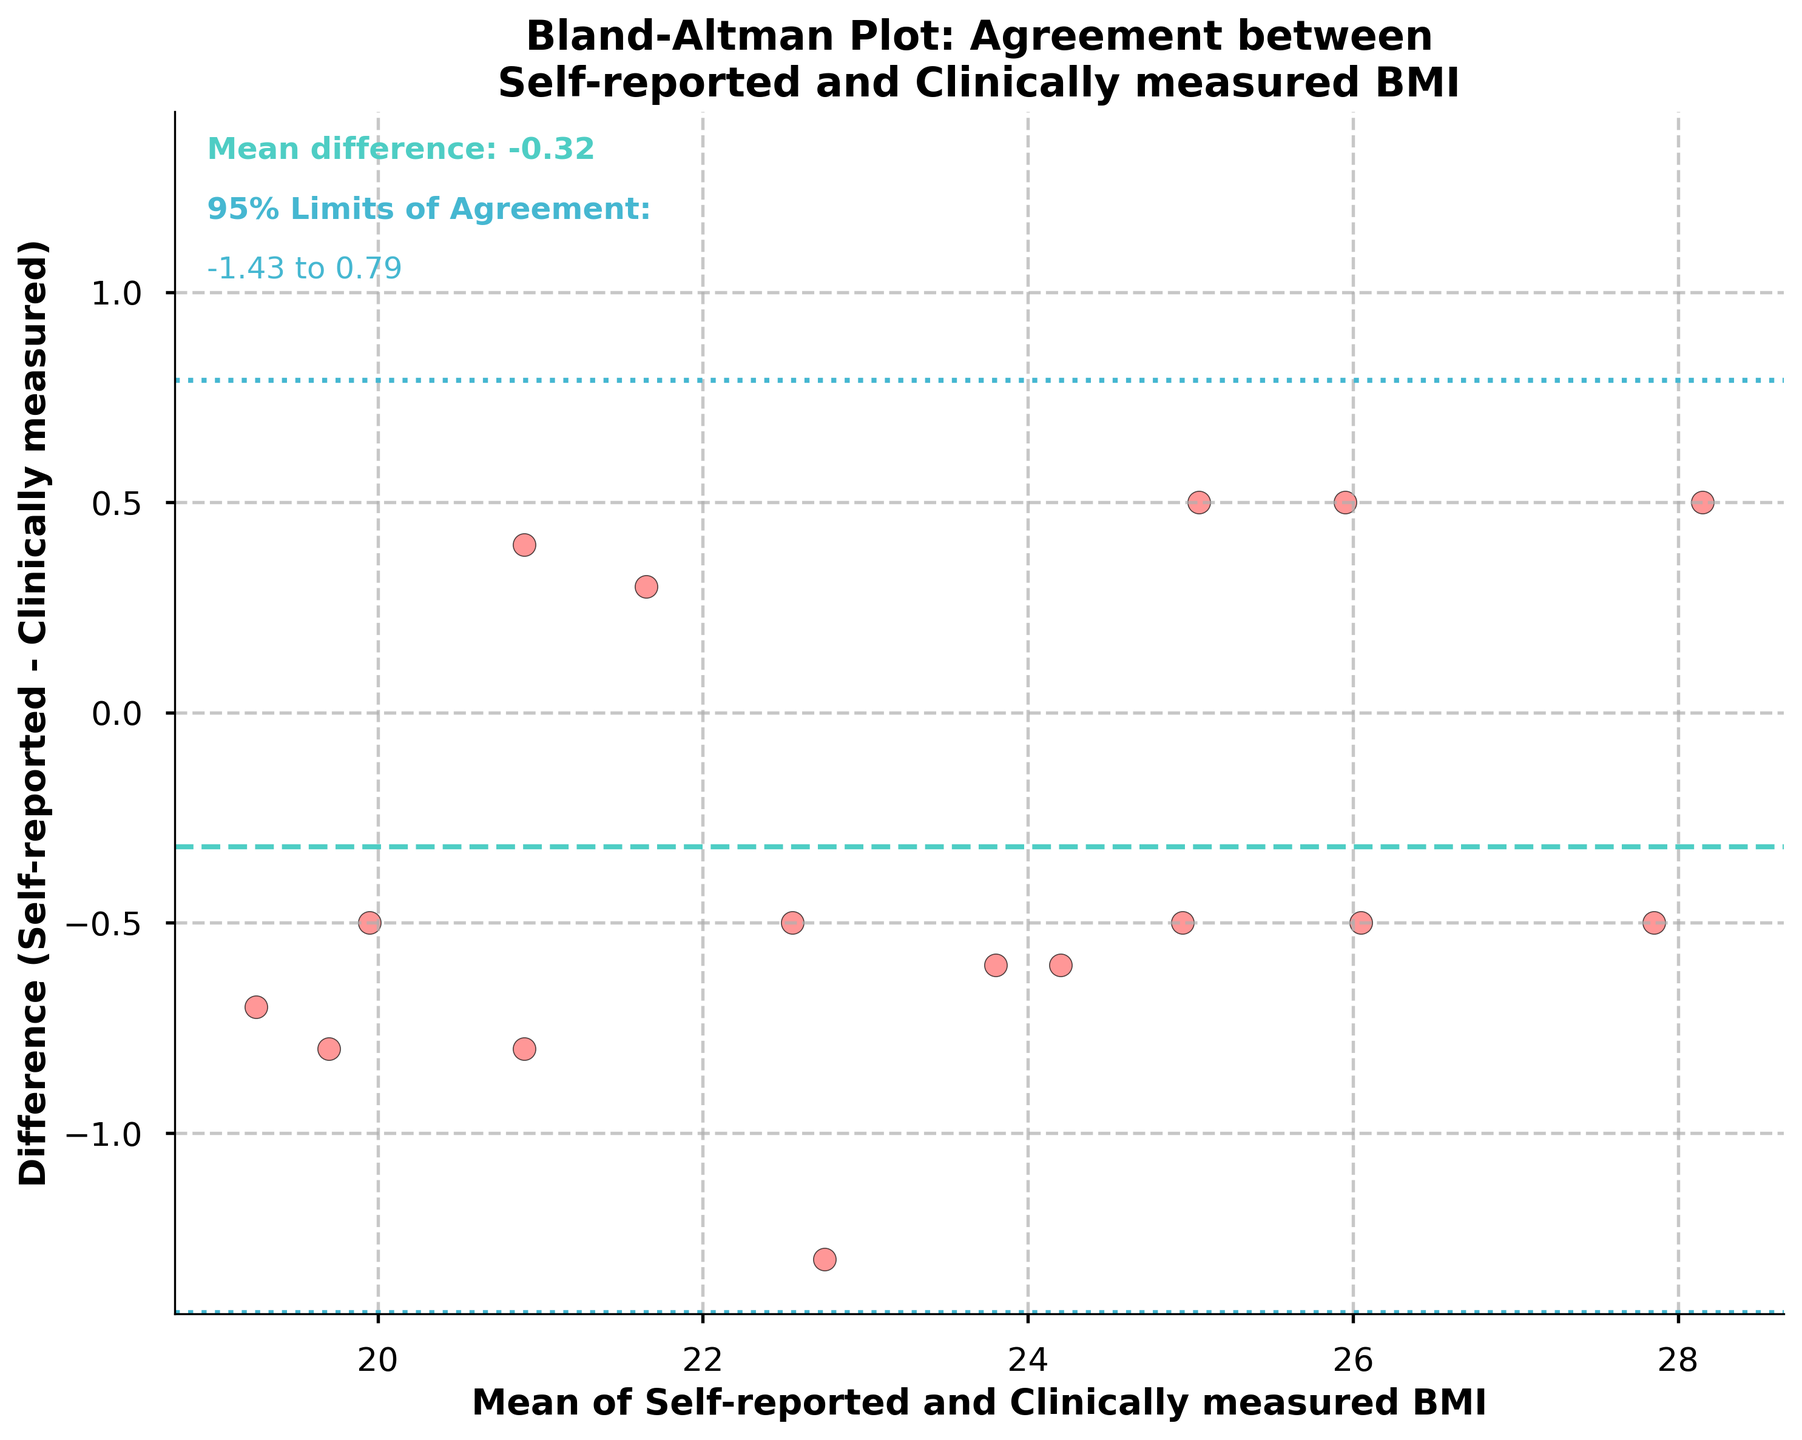What kind of plot is this? This plot is called a Bland-Altman plot, which is used to compare two measurement methods by plotting the differences between the methods against their averages.
Answer: Bland-Altman plot What does the title of the figure say? The title says, "Bland-Altman Plot: Agreement between Self-reported and Clinically measured BMI."
Answer: Bland-Altman Plot: Agreement between Self-reported and Clinically measured BMI What do the x-axis and y-axis represent in this plot? The x-axis represents the mean of Self-reported and Clinically measured BMI, while the y-axis represents the difference between Self-reported and Clinically measured BMI.
Answer: x-axis: mean of BMIs, y-axis: difference of BMIs How many data points are plotted in the figure? Each subject has one data point where the mean BMI is plotted against the difference. There are 16 subjects, so there are 16 data points.
Answer: 16 What color is used to represent the scatter points? The scatter points are represented in a reddish color with an alpha transparency for visual clarity.
Answer: Reddish What is the mean difference line, and what color is it? The mean difference line represents the average difference between Self-reported and Clinically measured BMI and is shown in cyan color with a dashed line style.
Answer: Cyan What are the 95% limits of agreement and their colors? The 95% limits of agreement are represented by two dotted lines in a different shade of blue than the mean difference line, and they indicate the range within which 95% of the differences between the two measurement methods will lie.
Answer: Two shades of blue What is the mean difference between Self-reported and Clinically measured BMI? The mean difference is around -0.24, indicated by the dashed cyan line in the plot.
Answer: -0.24 What are the calculated limits of agreement presented in the figure? The limits of agreement, presented as text annotations, are approximately -1.28 and +0.80. This means most differences between self-reported and clinically measured BMI fall within this range.
Answer: -1.28 to +0.80 Are there any data points outside the limits of agreement? Observing the scatter points and comparing them to the dotted lines of the limits of agreement, we see that all data points fall within the range, indicating good agreement overall.
Answer: No 